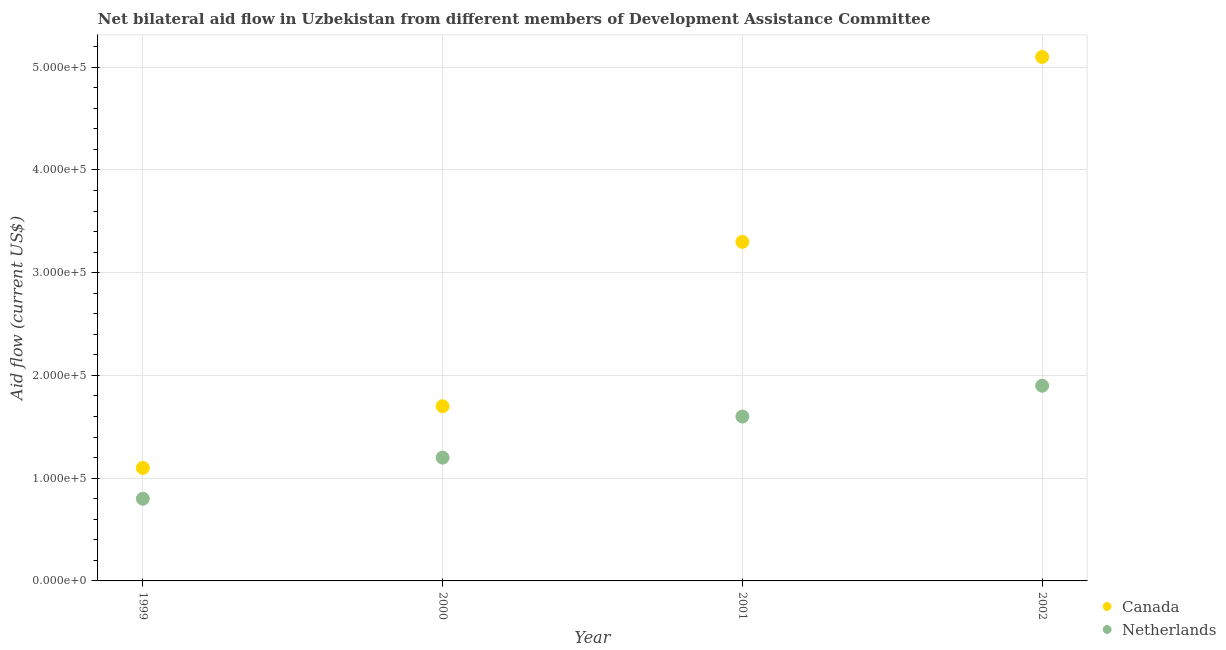Is the number of dotlines equal to the number of legend labels?
Keep it short and to the point. Yes. What is the amount of aid given by canada in 2002?
Provide a succinct answer. 5.10e+05. Across all years, what is the maximum amount of aid given by netherlands?
Provide a succinct answer. 1.90e+05. Across all years, what is the minimum amount of aid given by netherlands?
Your answer should be compact. 8.00e+04. In which year was the amount of aid given by netherlands maximum?
Your answer should be very brief. 2002. In which year was the amount of aid given by netherlands minimum?
Your response must be concise. 1999. What is the total amount of aid given by netherlands in the graph?
Ensure brevity in your answer.  5.50e+05. What is the difference between the amount of aid given by canada in 2000 and that in 2001?
Give a very brief answer. -1.60e+05. What is the difference between the amount of aid given by canada in 1999 and the amount of aid given by netherlands in 2000?
Provide a succinct answer. -10000. In the year 1999, what is the difference between the amount of aid given by canada and amount of aid given by netherlands?
Your answer should be very brief. 3.00e+04. What is the ratio of the amount of aid given by canada in 2000 to that in 2002?
Keep it short and to the point. 0.33. What is the difference between the highest and the second highest amount of aid given by canada?
Your answer should be very brief. 1.80e+05. What is the difference between the highest and the lowest amount of aid given by canada?
Your answer should be compact. 4.00e+05. Is the sum of the amount of aid given by canada in 1999 and 2002 greater than the maximum amount of aid given by netherlands across all years?
Give a very brief answer. Yes. Is the amount of aid given by netherlands strictly greater than the amount of aid given by canada over the years?
Provide a short and direct response. No. How many years are there in the graph?
Provide a short and direct response. 4. Are the values on the major ticks of Y-axis written in scientific E-notation?
Offer a very short reply. Yes. Does the graph contain any zero values?
Your response must be concise. No. Does the graph contain grids?
Make the answer very short. Yes. Where does the legend appear in the graph?
Provide a succinct answer. Bottom right. What is the title of the graph?
Keep it short and to the point. Net bilateral aid flow in Uzbekistan from different members of Development Assistance Committee. Does "Constant 2005 US$" appear as one of the legend labels in the graph?
Offer a terse response. No. What is the Aid flow (current US$) in Canada in 2000?
Keep it short and to the point. 1.70e+05. What is the Aid flow (current US$) of Netherlands in 2000?
Keep it short and to the point. 1.20e+05. What is the Aid flow (current US$) of Netherlands in 2001?
Your response must be concise. 1.60e+05. What is the Aid flow (current US$) of Canada in 2002?
Your answer should be very brief. 5.10e+05. Across all years, what is the maximum Aid flow (current US$) of Canada?
Your answer should be compact. 5.10e+05. Across all years, what is the maximum Aid flow (current US$) in Netherlands?
Offer a very short reply. 1.90e+05. Across all years, what is the minimum Aid flow (current US$) of Canada?
Keep it short and to the point. 1.10e+05. Across all years, what is the minimum Aid flow (current US$) of Netherlands?
Provide a succinct answer. 8.00e+04. What is the total Aid flow (current US$) of Canada in the graph?
Your answer should be very brief. 1.12e+06. What is the difference between the Aid flow (current US$) of Netherlands in 1999 and that in 2000?
Give a very brief answer. -4.00e+04. What is the difference between the Aid flow (current US$) in Canada in 1999 and that in 2001?
Offer a terse response. -2.20e+05. What is the difference between the Aid flow (current US$) in Netherlands in 1999 and that in 2001?
Your answer should be compact. -8.00e+04. What is the difference between the Aid flow (current US$) in Canada in 1999 and that in 2002?
Provide a short and direct response. -4.00e+05. What is the difference between the Aid flow (current US$) of Netherlands in 1999 and that in 2002?
Give a very brief answer. -1.10e+05. What is the difference between the Aid flow (current US$) in Netherlands in 2000 and that in 2002?
Give a very brief answer. -7.00e+04. What is the difference between the Aid flow (current US$) of Canada in 1999 and the Aid flow (current US$) of Netherlands in 2000?
Provide a short and direct response. -10000. What is the difference between the Aid flow (current US$) in Canada in 1999 and the Aid flow (current US$) in Netherlands in 2002?
Ensure brevity in your answer.  -8.00e+04. What is the difference between the Aid flow (current US$) of Canada in 2000 and the Aid flow (current US$) of Netherlands in 2001?
Offer a very short reply. 10000. What is the difference between the Aid flow (current US$) in Canada in 2001 and the Aid flow (current US$) in Netherlands in 2002?
Ensure brevity in your answer.  1.40e+05. What is the average Aid flow (current US$) in Netherlands per year?
Your response must be concise. 1.38e+05. In the year 2000, what is the difference between the Aid flow (current US$) in Canada and Aid flow (current US$) in Netherlands?
Ensure brevity in your answer.  5.00e+04. In the year 2001, what is the difference between the Aid flow (current US$) of Canada and Aid flow (current US$) of Netherlands?
Ensure brevity in your answer.  1.70e+05. What is the ratio of the Aid flow (current US$) in Canada in 1999 to that in 2000?
Your response must be concise. 0.65. What is the ratio of the Aid flow (current US$) in Netherlands in 1999 to that in 2000?
Keep it short and to the point. 0.67. What is the ratio of the Aid flow (current US$) in Canada in 1999 to that in 2001?
Your answer should be compact. 0.33. What is the ratio of the Aid flow (current US$) of Netherlands in 1999 to that in 2001?
Your answer should be compact. 0.5. What is the ratio of the Aid flow (current US$) in Canada in 1999 to that in 2002?
Your answer should be very brief. 0.22. What is the ratio of the Aid flow (current US$) in Netherlands in 1999 to that in 2002?
Your answer should be very brief. 0.42. What is the ratio of the Aid flow (current US$) in Canada in 2000 to that in 2001?
Offer a very short reply. 0.52. What is the ratio of the Aid flow (current US$) in Netherlands in 2000 to that in 2001?
Your answer should be compact. 0.75. What is the ratio of the Aid flow (current US$) in Netherlands in 2000 to that in 2002?
Offer a very short reply. 0.63. What is the ratio of the Aid flow (current US$) of Canada in 2001 to that in 2002?
Your answer should be compact. 0.65. What is the ratio of the Aid flow (current US$) of Netherlands in 2001 to that in 2002?
Make the answer very short. 0.84. What is the difference between the highest and the second highest Aid flow (current US$) of Netherlands?
Keep it short and to the point. 3.00e+04. 